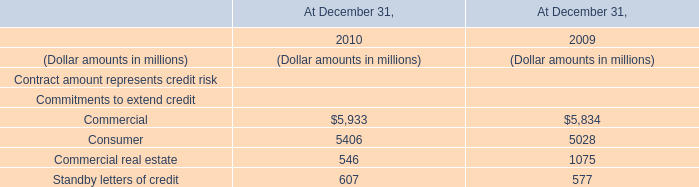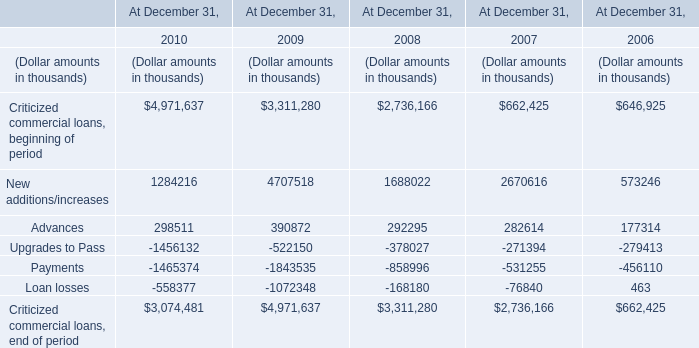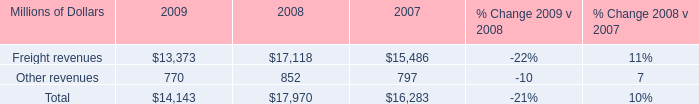how much of the 2010 capital expenditures are devoted to expenditures for ptc? 
Computations: (200 / (2.5 * 1000))
Answer: 0.08. 